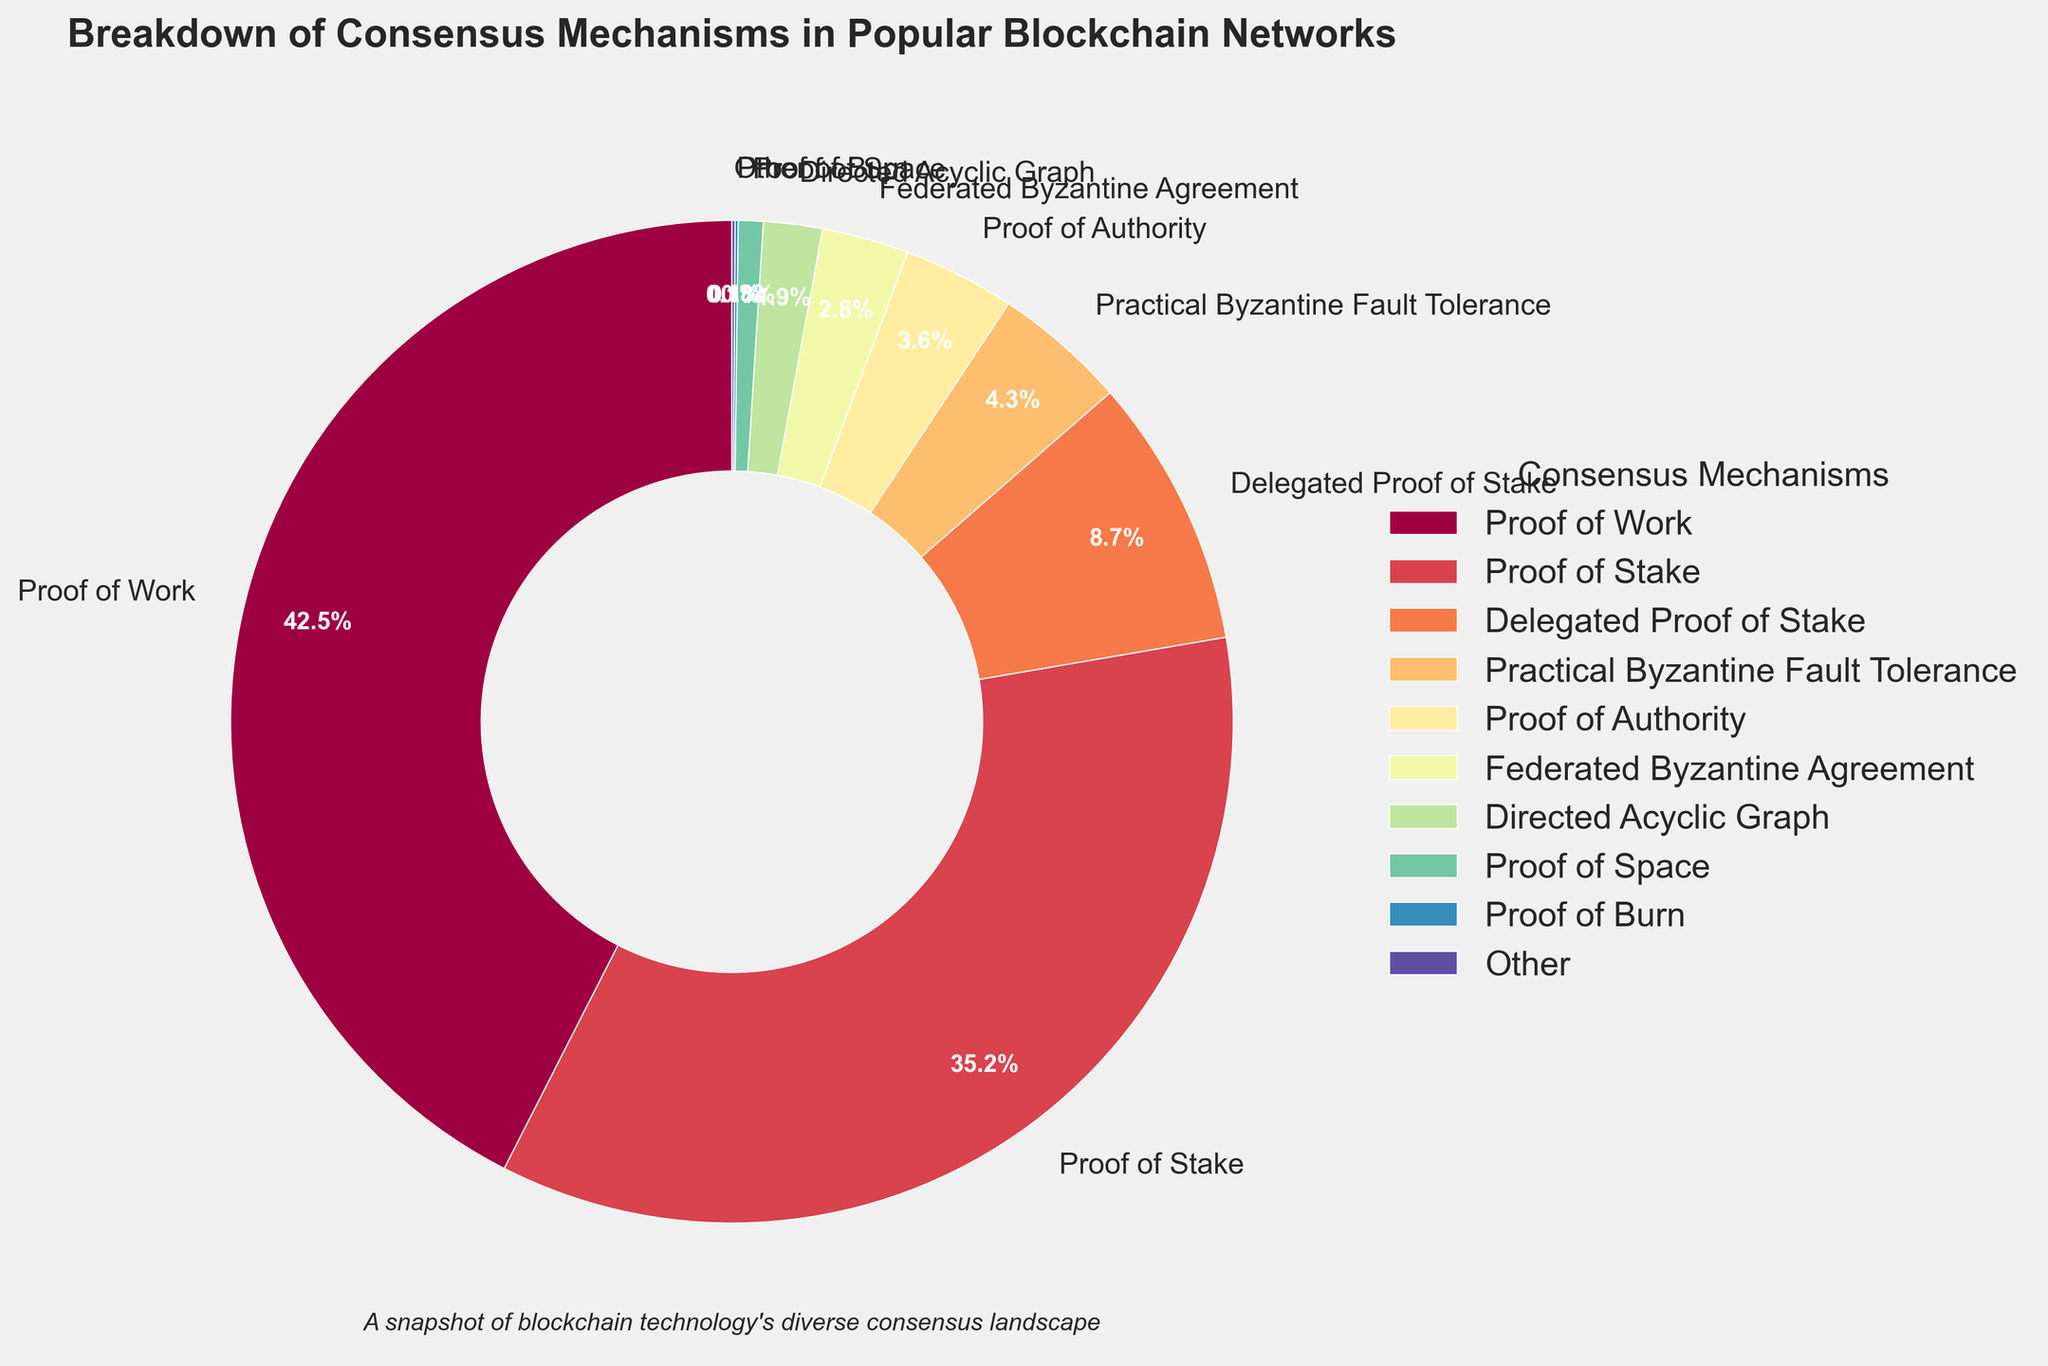What is the most used consensus mechanism in popular blockchain networks? The figure shows the breakdown of various consensus mechanisms, and Proof of Work has the largest slice of the pie chart at 42.5%.
Answer: Proof of Work What percentage of consensus mechanisms is represented by Proof of Stake and Delegated Proof of Stake combined? From the chart, Proof of Stake is 35.2% and Delegated Proof of Stake is 8.7%. Adding these together: 35.2 + 8.7 = 43.9%.
Answer: 43.9% Which consensus mechanism is the least used? The figure indicates that Proof of Burn and Other both have the smallest slices, each at 0.1%.
Answer: Proof of Burn, Other How many consensus mechanisms represent less than 5% each of the total distribution? By observing the pie chart, the following mechanisms have slices less than 5%: Practical Byzantine Fault Tolerance (4.3%), Proof of Authority (3.6%), Federated Byzantine Agreement (2.8%), Directed Acyclic Graph (1.9%), Proof of Space (0.8%), Proof of Burn (0.1%), and Other (0.1%). Counting these gives us 7 mechanisms.
Answer: 7 Compare the representation of Practical Byzantine Fault Tolerance and Directed Acyclic Graph in the chart. Which one is more significant, and by how much? Practical Byzantine Fault Tolerance has 4.3% while Directed Acyclic Graph has 1.9%. The difference is: 4.3 - 1.9 = 2.4%.
Answer: Practical Byzantine Fault Tolerance by 2.4% What is the combined percentage of Proof of Work, Proof of Stake, and Delegated Proof of Stake mechanisms? Adding the percentages for Proof of Work (42.5%), Proof of Stake (35.2%), and Delegated Proof of Stake (8.7%) gives: 42.5 + 35.2 + 8.7 = 86.4%.
Answer: 86.4% Which consensus mechanisms have a visually similar color due to the gradient used? By looking at the color spectrum in the chart, since the color palette is continuous, adjacent mechanisms such as Proof of Stake and Delegated Proof of Stake, or Proof of Authority and Federated Byzantine Agreement may have visually similar colors.
Answer: Proof of Stake and Delegated Proof of Stake, Proof of Authority and Federated Byzantine Agreement 